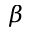<formula> <loc_0><loc_0><loc_500><loc_500>\beta</formula> 